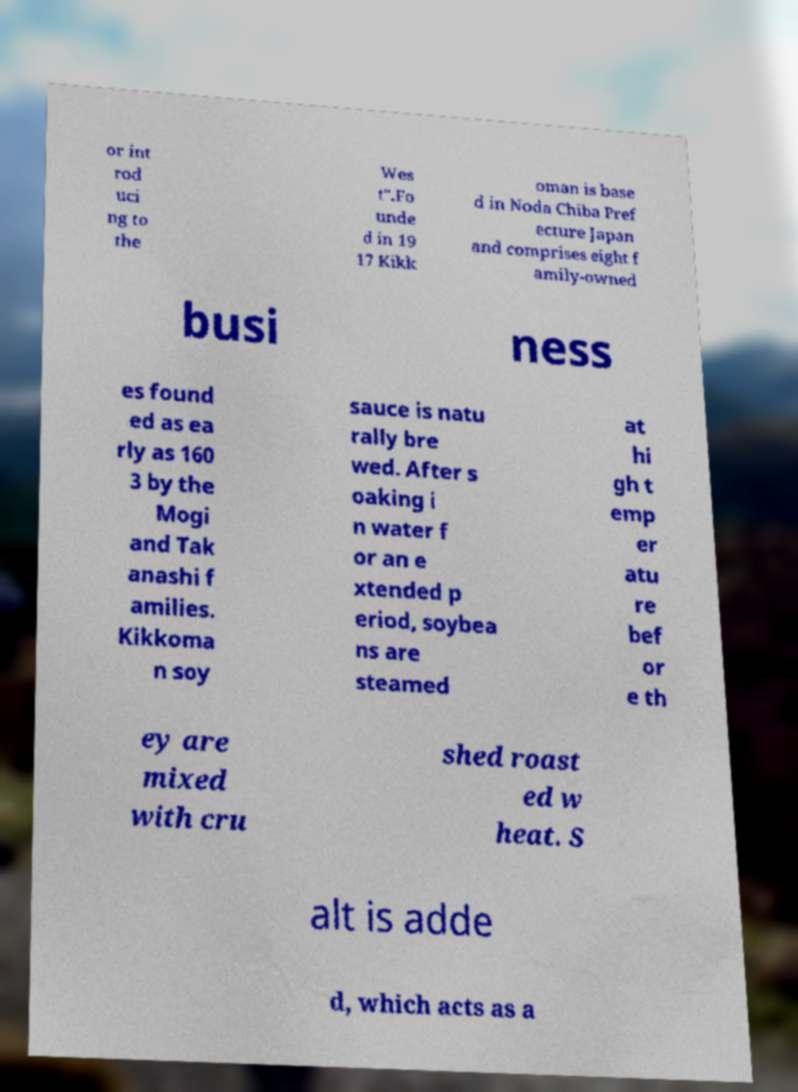Please identify and transcribe the text found in this image. or int rod uci ng to the Wes t".Fo unde d in 19 17 Kikk oman is base d in Noda Chiba Pref ecture Japan and comprises eight f amily-owned busi ness es found ed as ea rly as 160 3 by the Mogi and Tak anashi f amilies. Kikkoma n soy sauce is natu rally bre wed. After s oaking i n water f or an e xtended p eriod, soybea ns are steamed at hi gh t emp er atu re bef or e th ey are mixed with cru shed roast ed w heat. S alt is adde d, which acts as a 